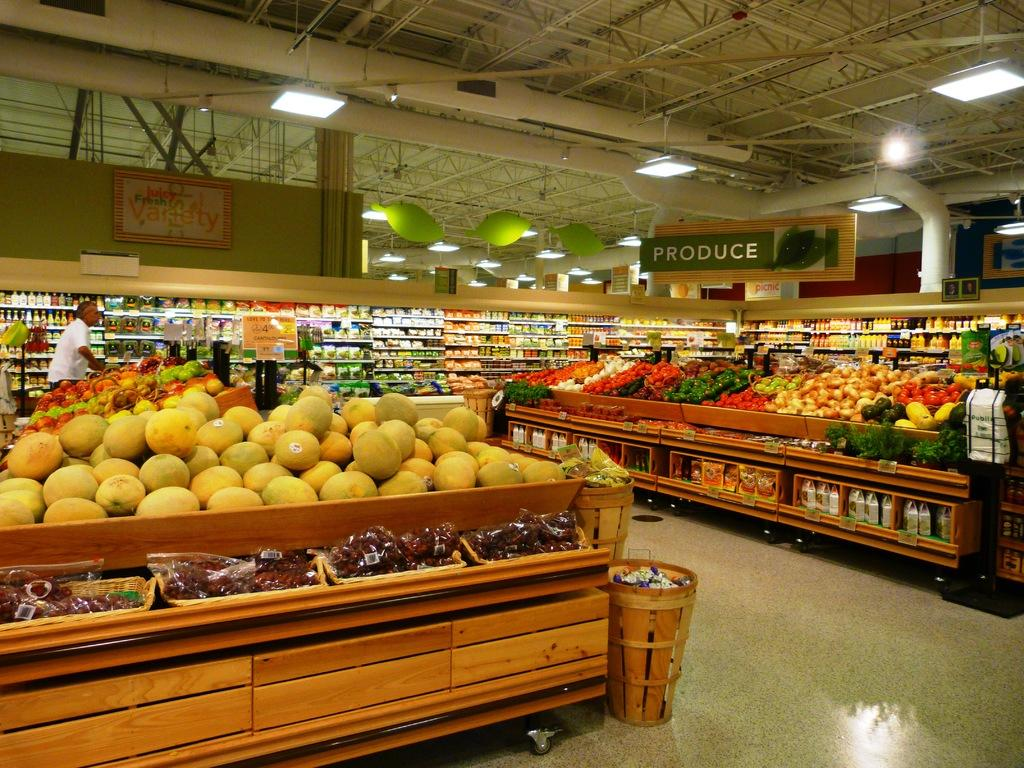<image>
Give a short and clear explanation of the subsequent image. A section of the store with a sign that says PRODUCE. 